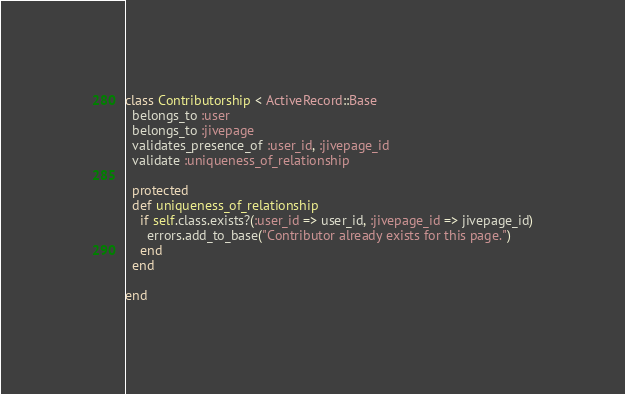Convert code to text. <code><loc_0><loc_0><loc_500><loc_500><_Ruby_>class Contributorship < ActiveRecord::Base
  belongs_to :user
  belongs_to :jivepage
  validates_presence_of :user_id, :jivepage_id
  validate :uniqueness_of_relationship

  protected
  def uniqueness_of_relationship
    if self.class.exists?(:user_id => user_id, :jivepage_id => jivepage_id)
      errors.add_to_base("Contributor already exists for this page.")
    end
  end

end
</code> 